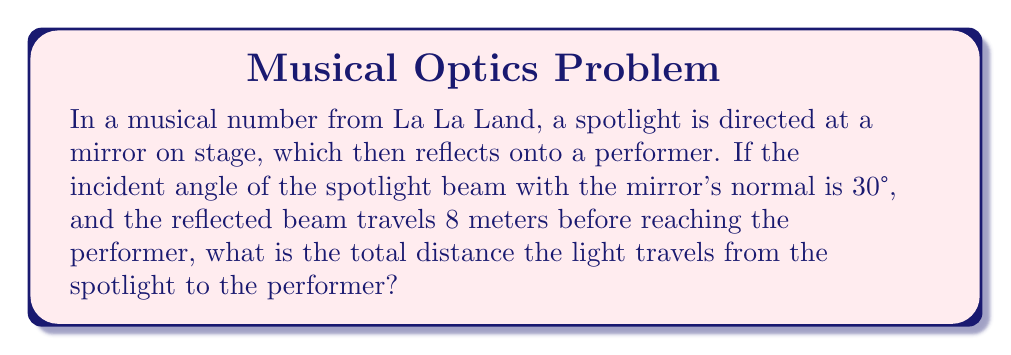Can you solve this math problem? Let's approach this step-by-step:

1) First, recall the law of reflection: the angle of incidence equals the angle of reflection. So, if the incident angle is 30°, the reflected angle is also 30°.

2) We can visualize this as a right triangle:

[asy]
import geometry;

size(200);

pair A = (0,0), B = (8,0), C = (0,4.619397662556434);

draw(A--B--C--A);

label("8m", B, S);
label("Performer", B, SE);
label("Mirror", A, SW);
label("Spotlight", C, NW);

draw((-1,0)--(9,0), dashed);
draw((0,-1)--(0,5), dashed);

label("30°", A, NE);
label("30°", A, SE);

draw(arc(A,0.5,90,60), Arrow);
draw(arc(A,0.5,90,120), Arrow);
[/asy]

3) The reflected beam forms the base of this triangle, which we know is 8 meters.

4) To find the height of the triangle (which represents the distance from the spotlight to the mirror), we can use trigonometry:

   $$\tan(30°) = \frac{\text{opposite}}{\text{adjacent}} = \frac{\text{height}}{8}$$

5) Solving for height:

   $$\text{height} = 8 \tan(30°) = 8 \cdot \frac{1}{\sqrt{3}} = \frac{8}{\sqrt{3}} \approx 4.62 \text{ meters}$$

6) Now we have both sides of the right triangle. To find the hypotenuse (which represents the path of the light from the spotlight to the mirror), we can use the Pythagorean theorem:

   $$c^2 = a^2 + b^2 = 8^2 + (\frac{8}{\sqrt{3}})^2 = 64 + \frac{64}{3} = \frac{256}{3}$$

   $$c = \sqrt{\frac{256}{3}} = \frac{16}{\sqrt{3}} \approx 9.24 \text{ meters}$$

7) The total distance is the sum of the distance from the spotlight to the mirror and from the mirror to the performer:

   $$\text{Total distance} = \frac{16}{\sqrt{3}} + 8 = \frac{16 + 8\sqrt{3}}{\sqrt{3}} \approx 17.24 \text{ meters}$$
Answer: $\frac{16 + 8\sqrt{3}}{\sqrt{3}}$ meters 